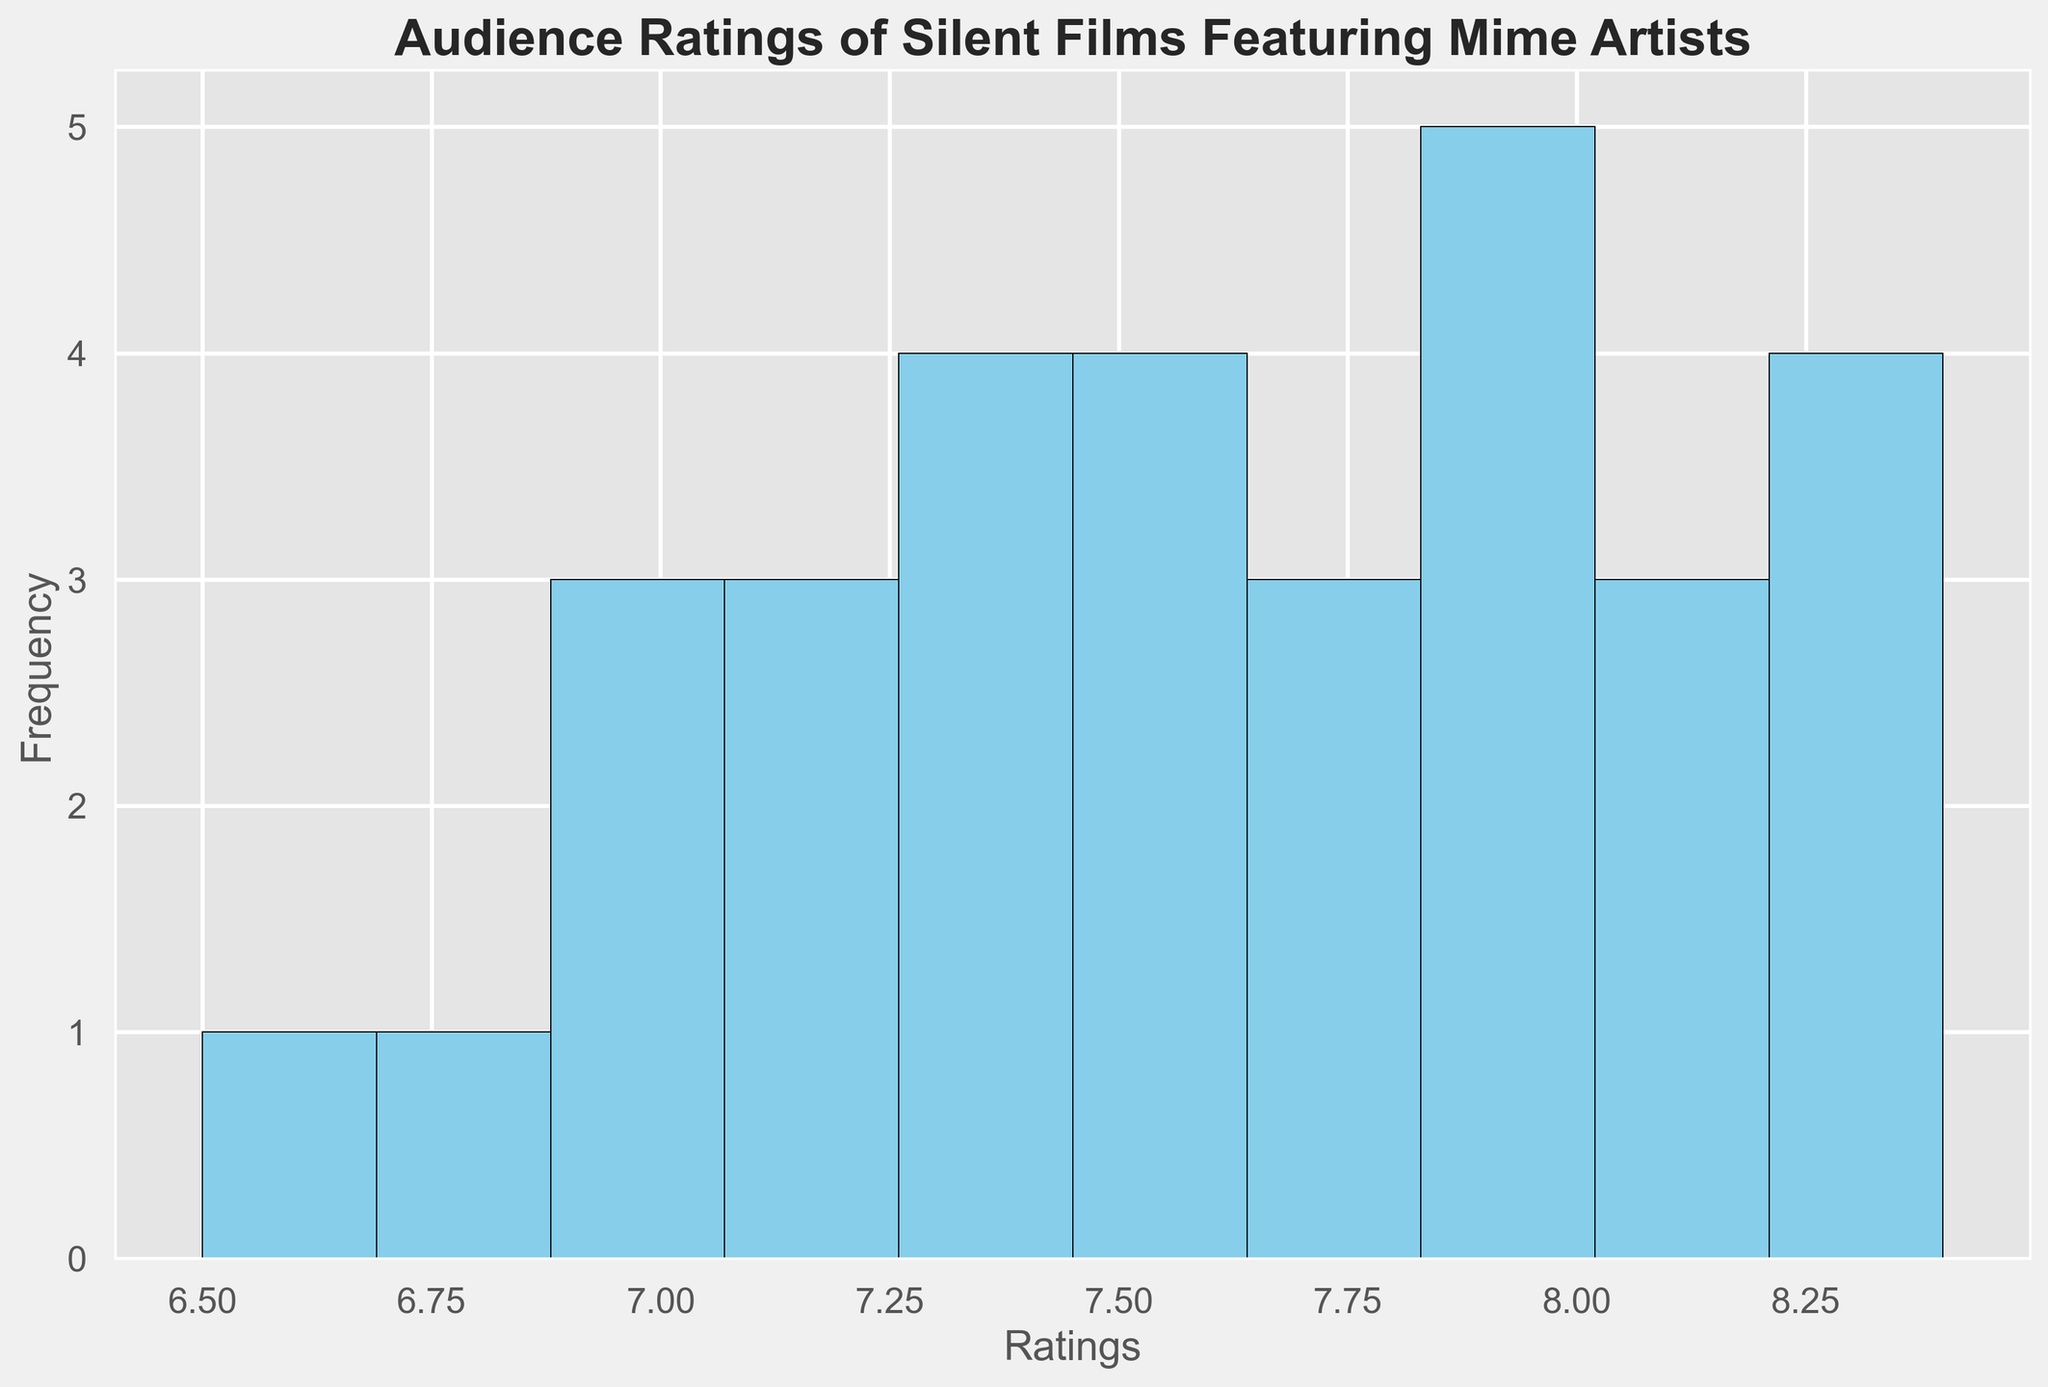How many films have ratings between 7.5 and 8.0? To find the number of films with ratings between 7.5 and 8.0, count the bars that represent this interval on the histogram. Look for the bars between the 7.5 and 8.0 marks on the x-axis and sum their heights.
Answer: 7 What is the most frequent rating range for these films? The most frequent rating range is represented by the tallest bar in the histogram. Identify this tallest bar and note the rating range it covers by checking the corresponding interval on the x-axis.
Answer: 8.0 to 8.5 How do the number of films with ratings less than 7.0 compare to those higher than 8.0? Count the number of bars representing ratings less than 7.0 and the number of bars representing ratings higher than 8.0. Compare these counts to determine which is greater.
Answer: More films have ratings higher than 8.0 What is the overall distribution shape of the ratings? Observe the general height and spread of the bars across the x-axis to determine the shape. Consider whether the distribution is skewed or symmetric, and notice if there are any peaks or clustering.
Answer: Slightly right-skewed with a peak around 8.0-8.5 Which rating bucket contains the fewest number of films? Look for the shortest bar in the histogram and identify the rating range it represents according to the x-axis labels.
Answer: 6.5 to 7.0 What is the average rating of the silent films? To find the average rating, calculate the sum of all the ratings and divide by the number of ratings. Knowing all the ratings: (7.5 + 8.0 + 6.8 + 7.2 + 8.3 + 7.9 + 6.5 + 7.6 + 8.1 + 7.4 + 8.2 + 7.0 + 7.3 + 8.0 + 6.9 + 7.8 + 8.4 + 7.1 + 7.5 + 8.3 + 7.2 + 7.9 + 8.0 + 7.6 + 7.7 + 7.4 + 7.8 + 8.4 + 7.0 + 7.3 + 8.2) / 31
Answer: 7.73 How many films have a rating higher than the average rating? Once you calculate the average rating of 7.73, count the number of films with ratings greater than 7.73 by looking at the histogram.
Answer: 15 Which year had the lowest audience rating? Check the data to find the lowest rating, and then identify the corresponding year. From the data, the lowest rating of 6.5 occurred in 1926.
Answer: 1926 Is there any rating value that is an outlier? Determine if there's a rating far from others by looking for bars that stand alone or are much shorter/taller. Based on the histogram, ratings like 6.5 and 8.4 might be considered outliers.
Answer: 8.4 How consistent are the audience ratings across the years? To evaluate consistency, observe the spread and height of the bars. If the bars are fairly uniform with no extreme highs or lows, the ratings are consistent.
Answer: Moderately consistent 